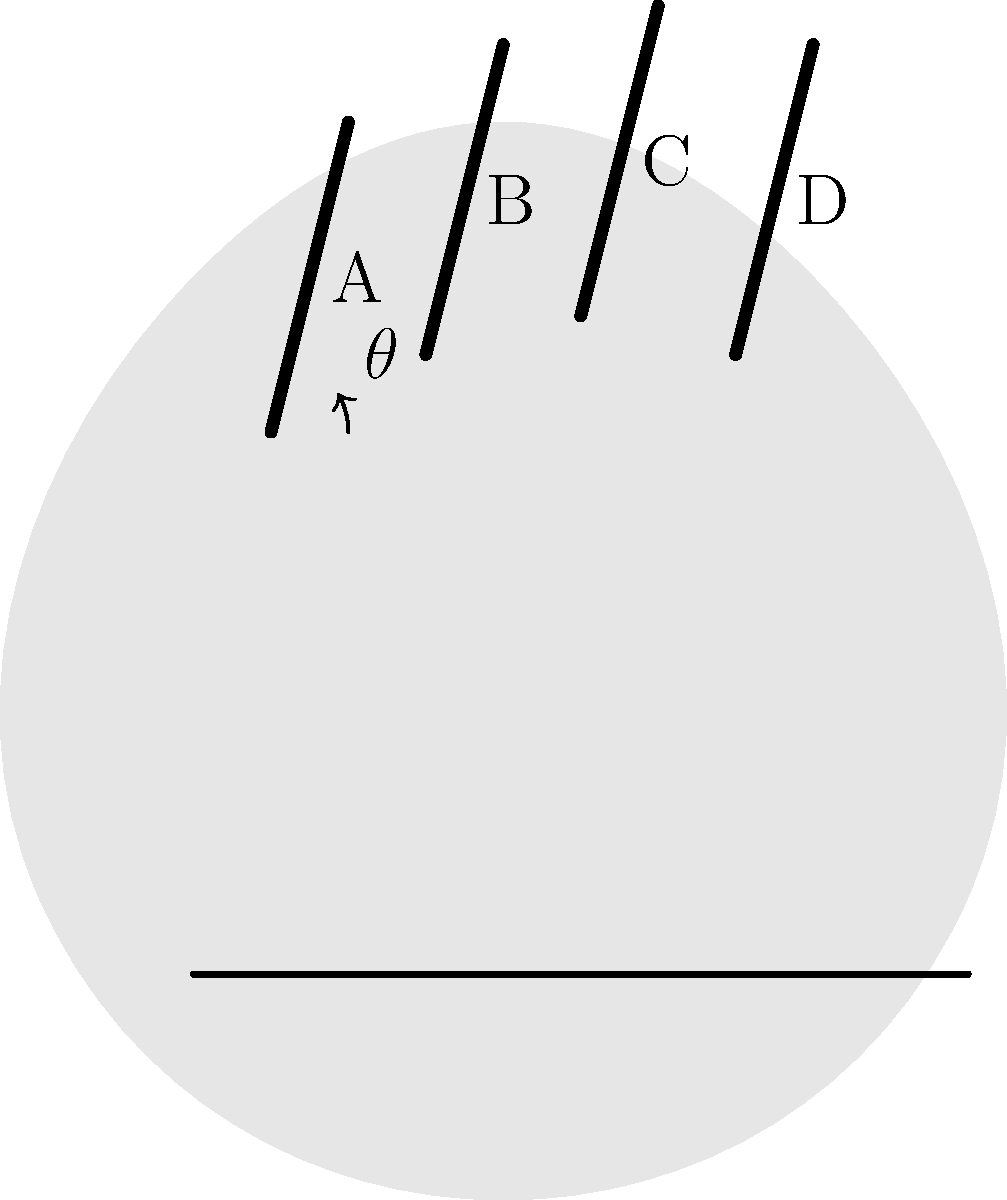In the context of violin playing, which finger (labeled A, B, C, or D in the simplified hand skeleton) experiences the greatest angular displacement $\theta$ when moving from an open string to a high position on the fingerboard? How does this affect the biomechanics of finger movements and what implications does it have for developing music software for violin sampling and remixing? To answer this question, we need to consider the biomechanics of finger movements on the violin fingerboard:

1. Finger position: Finger A (index finger) is closest to the nut of the violin, while finger D (pinky) is farthest.

2. Angular displacement: When moving from an open string to a high position, all fingers need to stretch towards the bridge of the violin.

3. Finger length: Typically, the pinky (D) is the shortest finger, followed by the index (A), while the middle (B) and ring (C) fingers are longer.

4. Pivot point: The base knuckle of each finger acts as a pivot point for the angular displacement.

5. Biomechanical analysis:
   - Shorter fingers (A and D) need to rotate more to reach the same position as longer fingers.
   - The pinky (D) has the shortest length and is farthest from the nut, requiring the greatest angular displacement.
   - The index finger (A) has a slightly larger angular displacement than B and C but less than D.

6. Implications for music software development:
   - Different angular displacements affect the timing and pressure of each finger on the string.
   - The pinky's larger displacement may result in slightly delayed or less precise note changes.
   - Software should account for these biomechanical differences when processing and analyzing violin performances.
   - Remixing and sampling tools could incorporate finger-specific adjustments to improve authenticity and playability of generated melodies.

Therefore, finger D (pinky) experiences the greatest angular displacement, which affects its speed and precision in high positions. This knowledge can be used to create more realistic and ergonomic violin sampling and remixing tools.
Answer: Finger D (pinky), with implications for timing, pressure, and precision in high positions affecting software design for realistic violin sampling and remixing. 